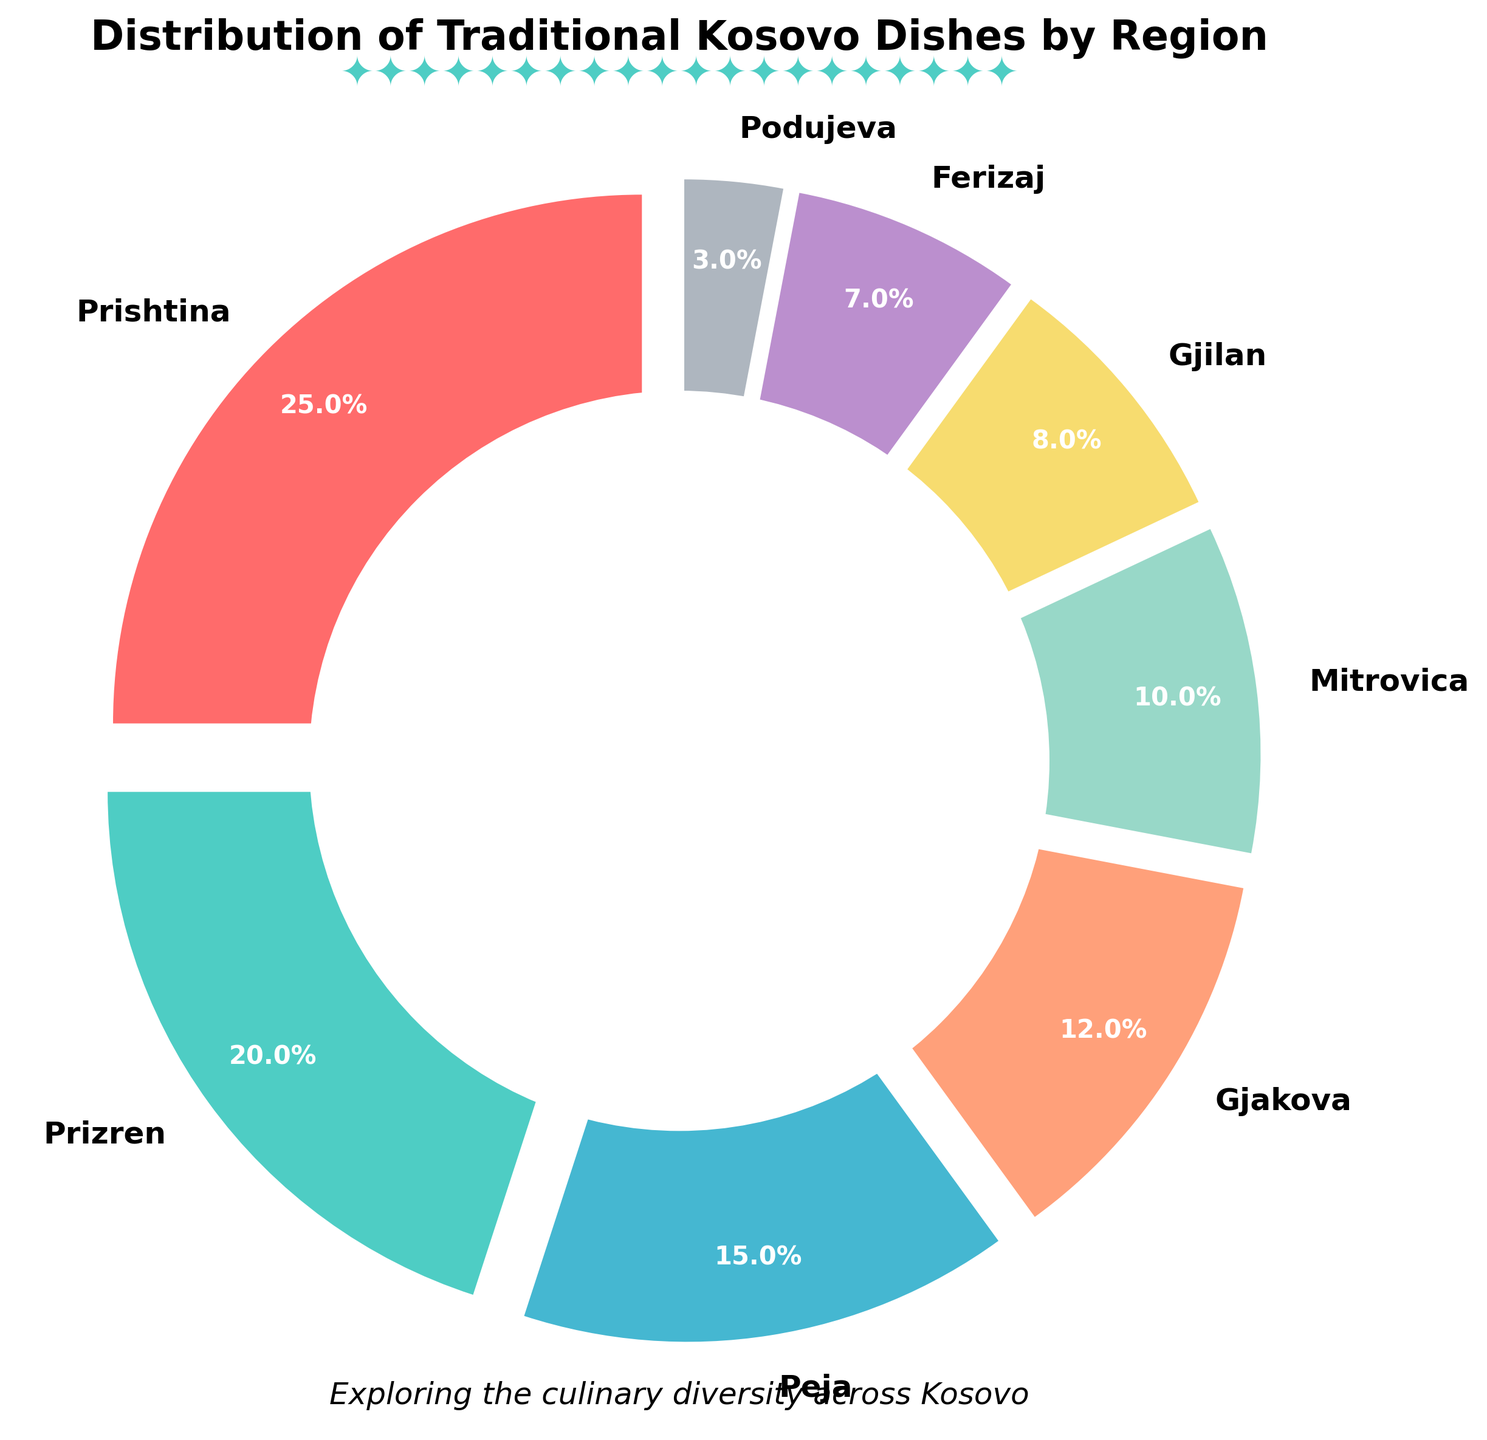Which region contributes the highest percentage of traditional Kosovo dishes? Observe the slice with the largest size and the highest percentage label, which corresponds to Prishtina, contributing 25%
Answer: Prishtina Which region has a lower percentage of traditional Kosovo dishes than Gjakova but higher than Gjilan? Compare the percentages of regions around Gjakova (12%) and Gjilan (8%); Mitrovica fits the criteria with 10%
Answer: Mitrovica What is the combined percentage of traditional dishes from Peja and Gjakova? Add the percentages of Peja (15%) and Gjakova (12%); 15% + 12% = 27%
Answer: 27% How much larger is the percentage of traditional dishes from Prizren compared to Ferizaj? Subtract the percentage of Ferizaj (7%) from Prizren (20%); 20% - 7% = 13%
Answer: 13% Which regions have a combined percentage equal to 45% of traditional Kosovo dishes? Add the percentages of combinations until reaching 45%; Prishtina (25%) and Peja (15%) and Podujeva (3%) sum up to 43%, while Prishtina (25%) and Prizren (20%) sum up to 45%
Answer: Prishtina and Prizren What is the difference in the distribution of traditional dishes between the region with the highest and the region with the lowest percentage? Subtract the smallest percentage (Podujeva, 3%) from the largest (Prishtina, 25%); 25% - 3% = 22%
Answer: 22% Which region's traditional dish percentage is closest to 10%? Compare the percentages to 10%, Mitrovica has exactly 10%
Answer: Mitrovica What is the average percentage of traditional dishes for Podujeva, Ferizaj, and Gjilan? Add the percentages of Podujeva (3%), Ferizaj (7%), and Gjilan (8%) and divide by 3; (3% + 7% + 8%) / 3 = 6%
Answer: 6% Among Gjilan and Podujeva, which region contributes more to the traditional dishes? Compare the percentages of Gjilan (8%) and Podujeva (3%)
Answer: Gjilan Are there more regions with a percentage above or below 10%? Count regions above 10% (Prishtina, Prizren, Peja, Gjakova) and below 10% (Mitrovica, Gjilan, Ferizaj, Podujeva); both counts are 4
Answer: Equal 